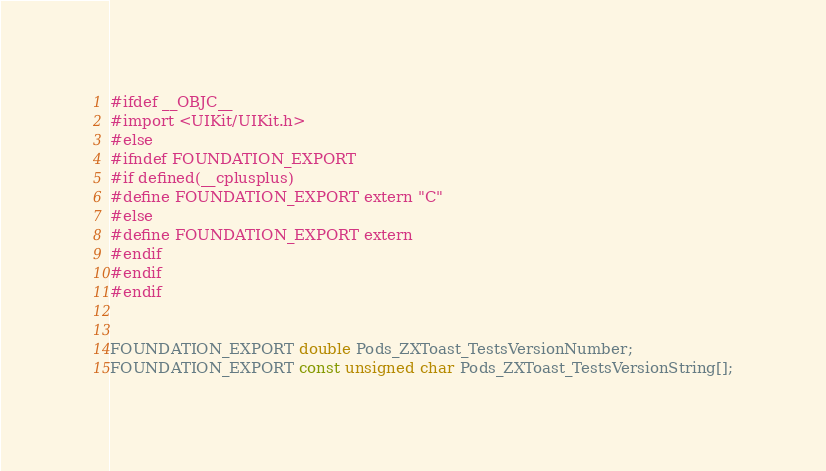Convert code to text. <code><loc_0><loc_0><loc_500><loc_500><_C_>#ifdef __OBJC__
#import <UIKit/UIKit.h>
#else
#ifndef FOUNDATION_EXPORT
#if defined(__cplusplus)
#define FOUNDATION_EXPORT extern "C"
#else
#define FOUNDATION_EXPORT extern
#endif
#endif
#endif


FOUNDATION_EXPORT double Pods_ZXToast_TestsVersionNumber;
FOUNDATION_EXPORT const unsigned char Pods_ZXToast_TestsVersionString[];

</code> 